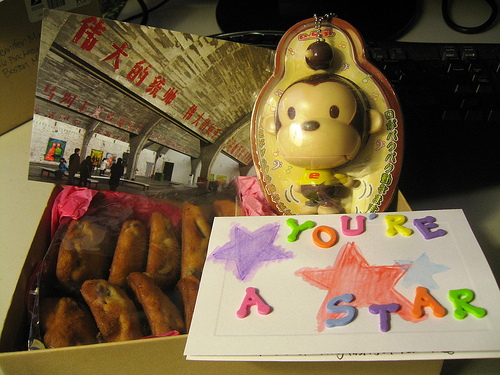<image>
Can you confirm if the green y is in front of the green r? No. The green y is not in front of the green r. The spatial positioning shows a different relationship between these objects. 